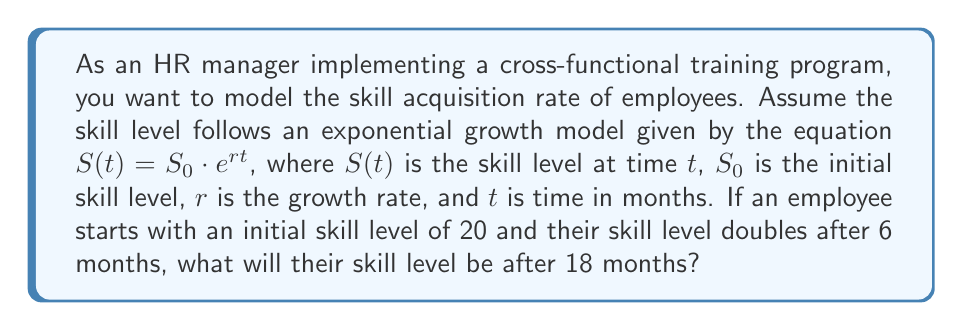Show me your answer to this math problem. 1. We are given the exponential growth model: $S(t) = S_0 \cdot e^{rt}$

2. Initial conditions:
   $S_0 = 20$ (initial skill level)
   $t = 6$ months (time for skill level to double)

3. After 6 months, the skill level doubles, so:
   $S(6) = 2S_0 = 2 \cdot 20 = 40$

4. We can use this information to find the growth rate $r$:
   $40 = 20 \cdot e^{6r}$
   $2 = e^{6r}$
   $\ln(2) = 6r$
   $r = \frac{\ln(2)}{6} \approx 0.1155$

5. Now that we have $r$, we can calculate the skill level after 18 months:
   $S(18) = S_0 \cdot e^{r \cdot 18}$
   $S(18) = 20 \cdot e^{0.1155 \cdot 18}$
   $S(18) = 20 \cdot e^{2.079}$
   $S(18) = 20 \cdot 8$
   $S(18) = 160$

Therefore, the employee's skill level after 18 months will be 160.
Answer: 160 